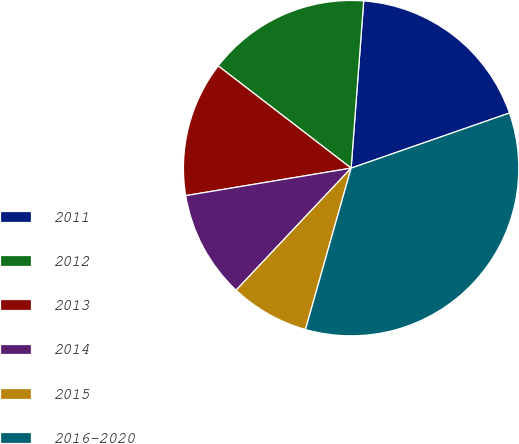Convert chart to OTSL. <chart><loc_0><loc_0><loc_500><loc_500><pie_chart><fcel>2011<fcel>2012<fcel>2013<fcel>2014<fcel>2015<fcel>2016-2020<nl><fcel>18.47%<fcel>15.76%<fcel>13.06%<fcel>10.35%<fcel>7.64%<fcel>34.72%<nl></chart> 